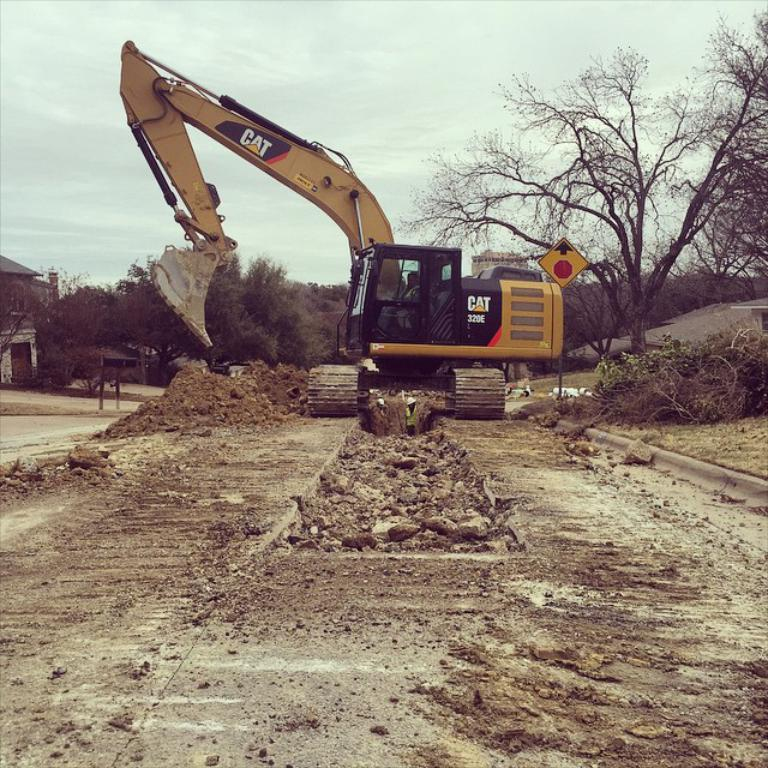What is the person in the image doing? The person is sitting inside a crane and ploughing soil from the land. What can be seen in the background of the image? There are trees in the background of the image. What is visible at the top of the image? The sky is visible in the image. What type of winter clothing is the person wearing in the image? The image does not show the person wearing any winter clothing, as there is no indication of winter or cold weather in the image. 